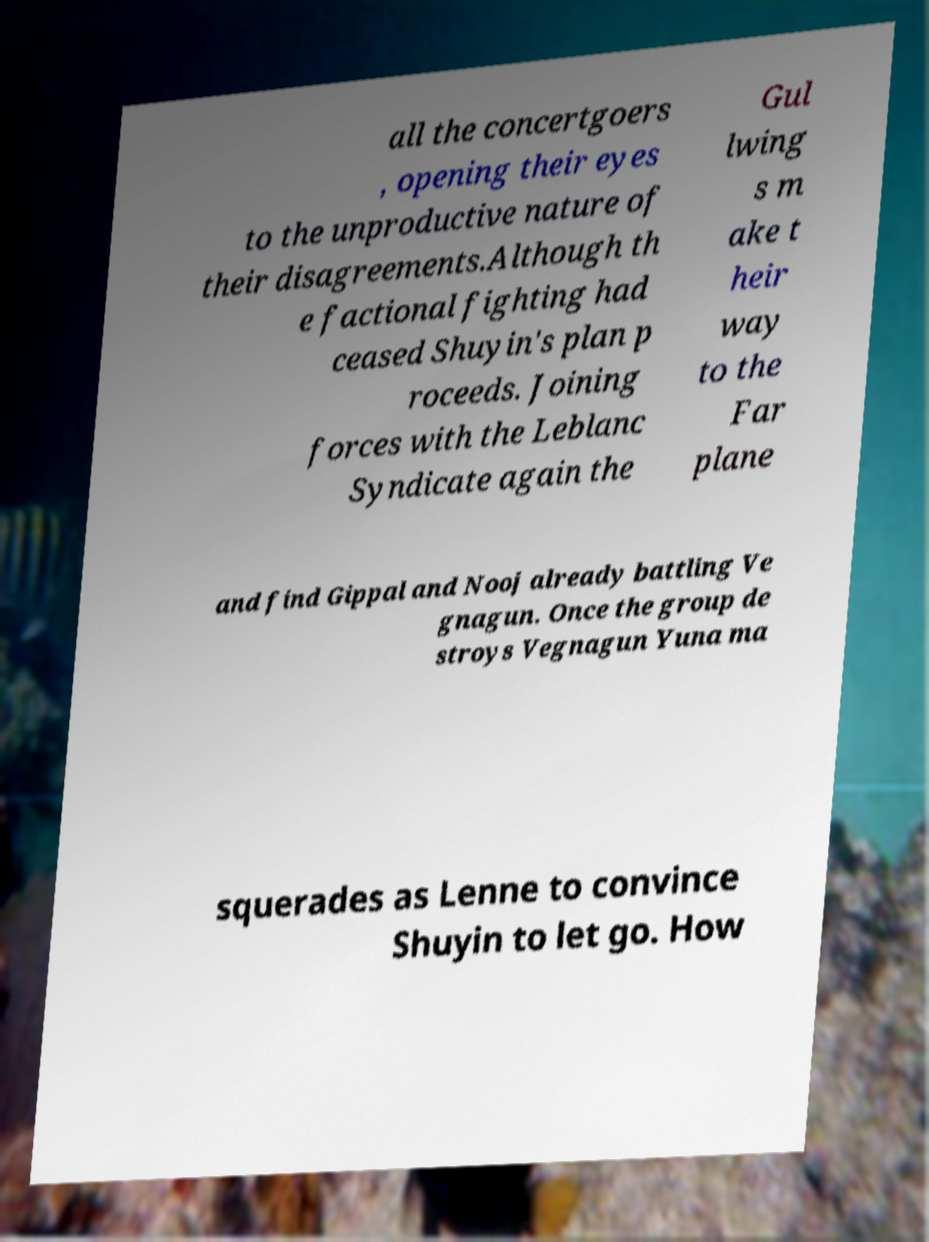Please identify and transcribe the text found in this image. all the concertgoers , opening their eyes to the unproductive nature of their disagreements.Although th e factional fighting had ceased Shuyin's plan p roceeds. Joining forces with the Leblanc Syndicate again the Gul lwing s m ake t heir way to the Far plane and find Gippal and Nooj already battling Ve gnagun. Once the group de stroys Vegnagun Yuna ma squerades as Lenne to convince Shuyin to let go. How 